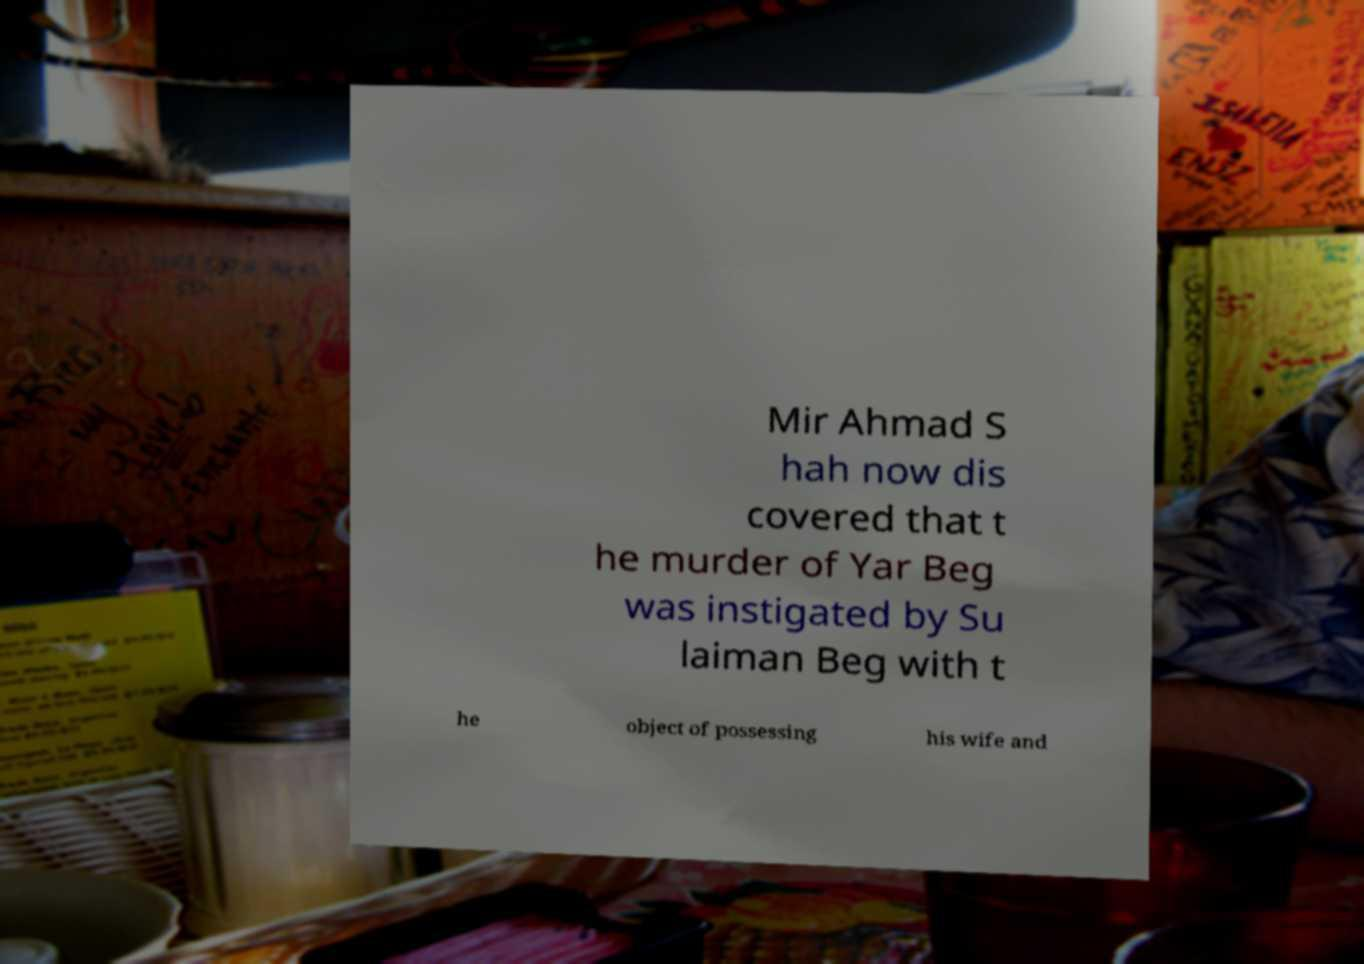Could you extract and type out the text from this image? Mir Ahmad S hah now dis covered that t he murder of Yar Beg was instigated by Su laiman Beg with t he object of possessing his wife and 